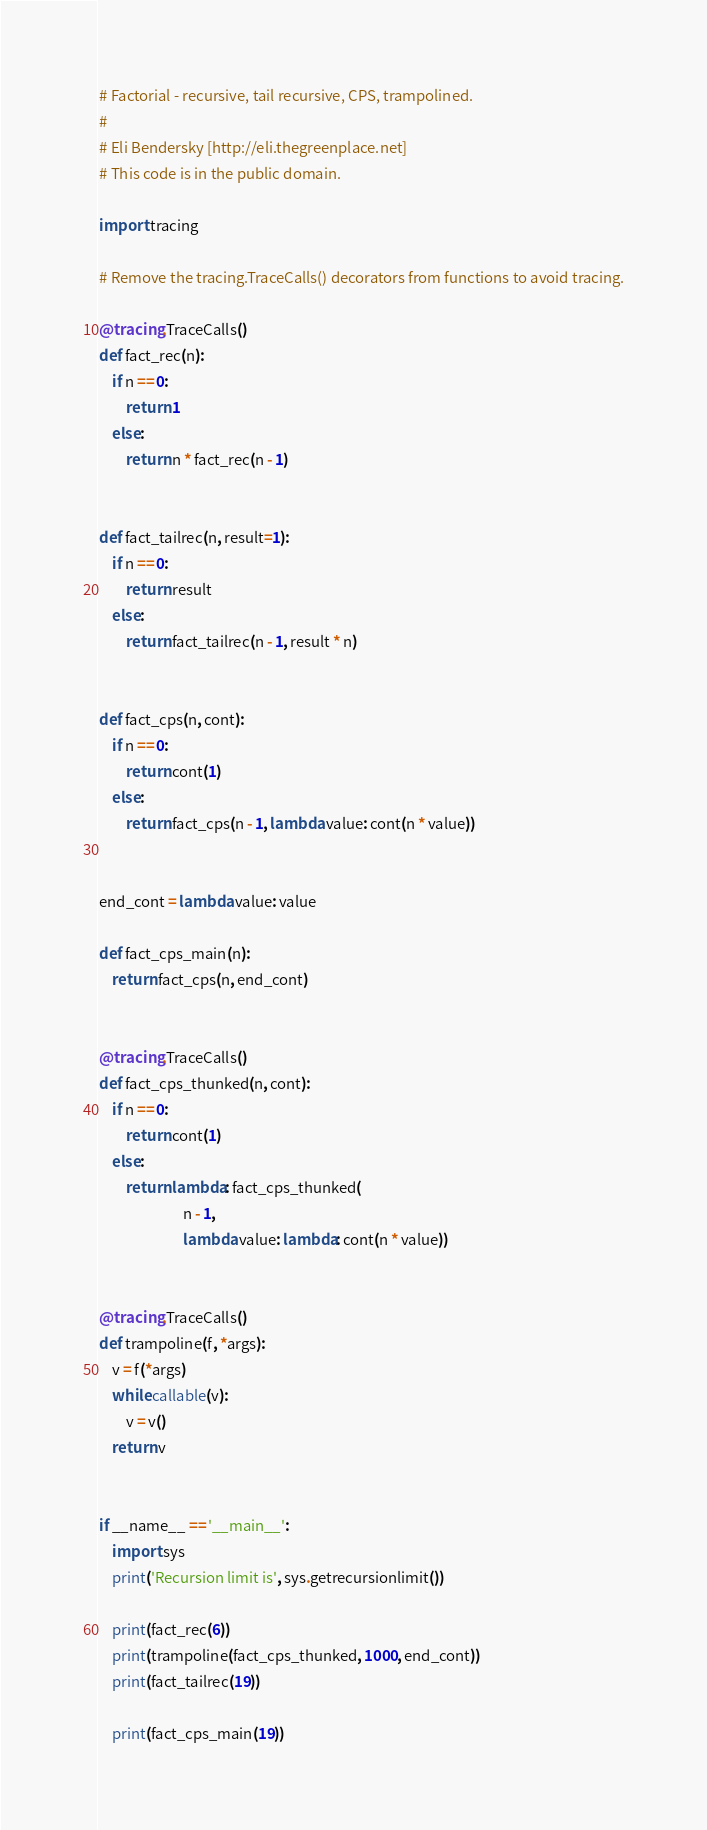Convert code to text. <code><loc_0><loc_0><loc_500><loc_500><_Python_># Factorial - recursive, tail recursive, CPS, trampolined.
#
# Eli Bendersky [http://eli.thegreenplace.net]
# This code is in the public domain.

import tracing

# Remove the tracing.TraceCalls() decorators from functions to avoid tracing.

@tracing.TraceCalls()
def fact_rec(n):
    if n == 0:
        return 1
    else:
        return n * fact_rec(n - 1)


def fact_tailrec(n, result=1):
    if n == 0:
        return result
    else:
        return fact_tailrec(n - 1, result * n)


def fact_cps(n, cont):
    if n == 0:
        return cont(1)
    else:
        return fact_cps(n - 1, lambda value: cont(n * value))


end_cont = lambda value: value

def fact_cps_main(n):
    return fact_cps(n, end_cont)


@tracing.TraceCalls()
def fact_cps_thunked(n, cont):
    if n == 0:
        return cont(1)
    else:
        return lambda: fact_cps_thunked(
                         n - 1,
                         lambda value: lambda: cont(n * value))


@tracing.TraceCalls()
def trampoline(f, *args):
    v = f(*args)
    while callable(v):
        v = v()
    return v


if __name__ == '__main__':
    import sys
    print('Recursion limit is', sys.getrecursionlimit())

    print(fact_rec(6))
    print(trampoline(fact_cps_thunked, 1000, end_cont))
    print(fact_tailrec(19))

    print(fact_cps_main(19))
</code> 